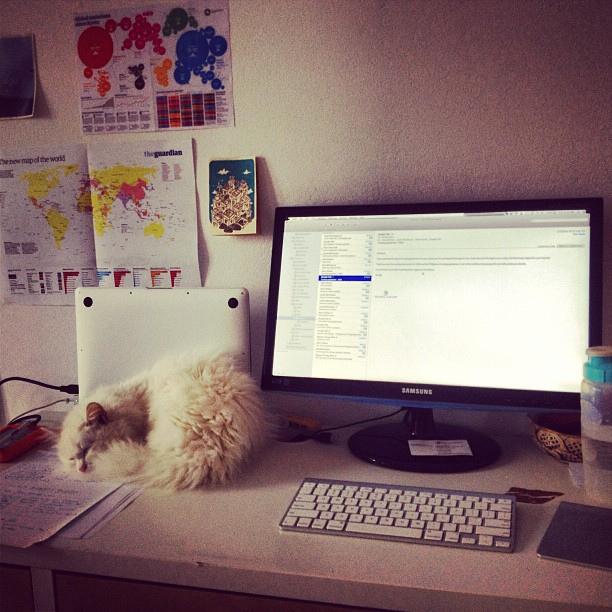What type of map is on the wall?
Short answer required. World. What gender is the person on the calendar?
Concise answer only. Female. What company logo is visible on the monitor?
Concise answer only. Samsung. Is the keyboard wired?
Quick response, please. No. Is the cat sleeping?
Quick response, please. Yes. How many animals are in the picture?
Give a very brief answer. 1. What color is the cat?
Quick response, please. White. How many monitors do you see?
Answer briefly. 1. 